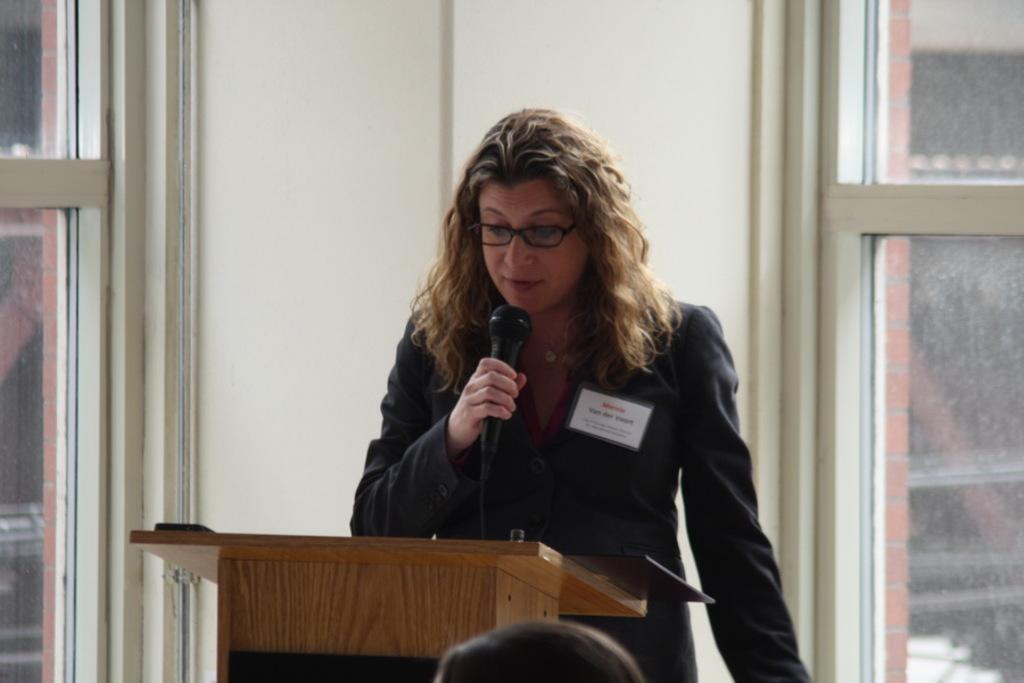In one or two sentences, can you explain what this image depicts? In the center of the image we can see a lady standing and holding a mic, before her there is a podium. In the background there is a wall and windows. 